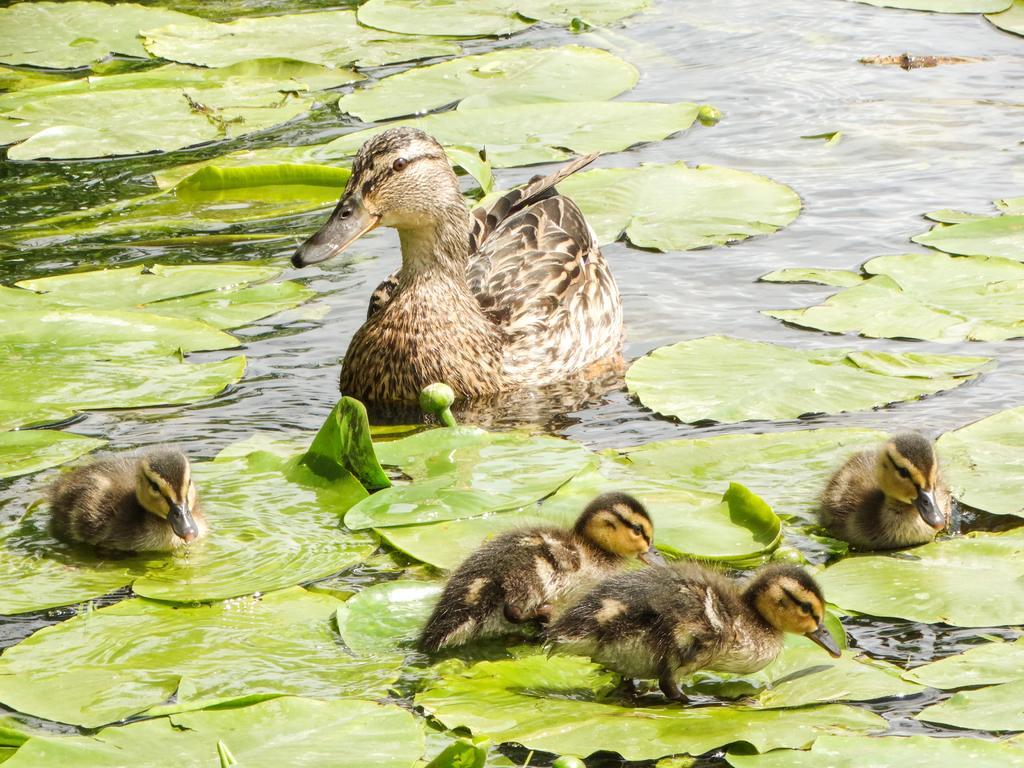Can you describe this image briefly? In this image we can see the lake, one duck with four ducklings in the water, some leaves and one bud in the water. 